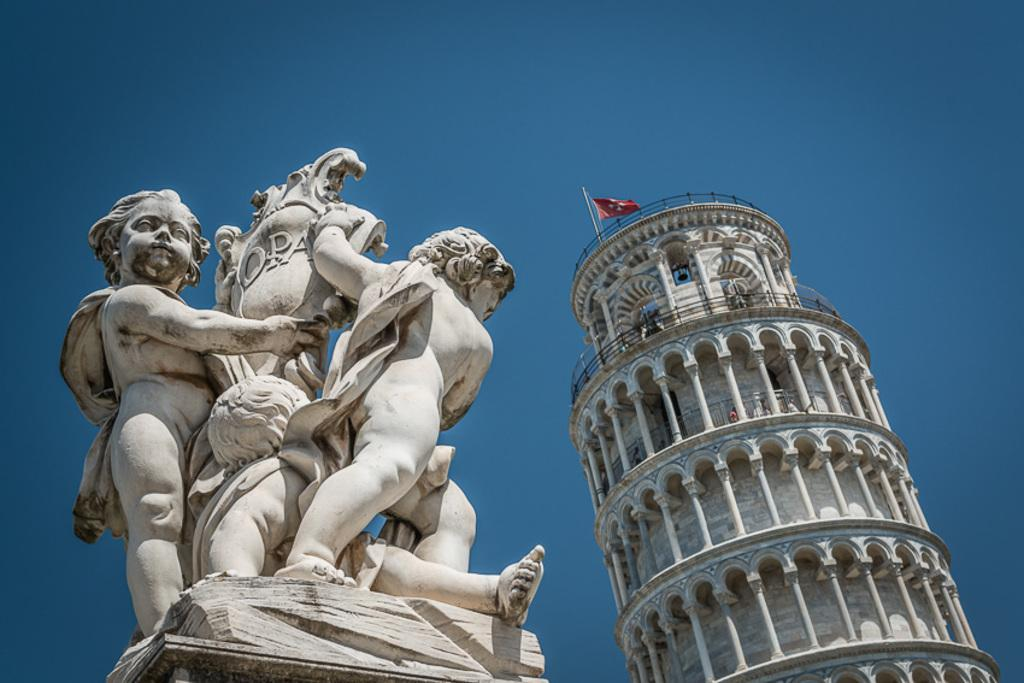What structure is located on the left side of the image? There is a statue on the left side of the image. What can be seen on the right side of the image? There is a tower on the right side of the image. What features does the tower have? The tower has windows and a flag. What is visible at the top of the image? The sky is visible at the top of the image. Can you tell me how many goldfish are swimming in the tower in the image? There are no goldfish present in the image; the tower has windows and a flag. What type of machine is depicted in the image? There is no machine depicted in the image; it features a statue, a tower, and the sky. 